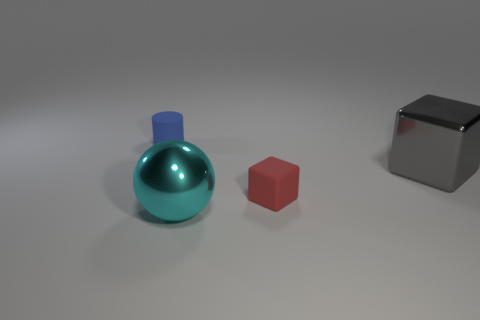Add 2 small gray matte cylinders. How many objects exist? 6 Subtract all small blue rubber objects. Subtract all big cyan objects. How many objects are left? 2 Add 4 big cyan metal things. How many big cyan metal things are left? 5 Add 1 large gray cylinders. How many large gray cylinders exist? 1 Subtract 1 red cubes. How many objects are left? 3 